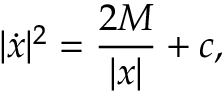<formula> <loc_0><loc_0><loc_500><loc_500>| { \dot { x } } | ^ { 2 } = { \frac { 2 M } { | x | } } + c ,</formula> 